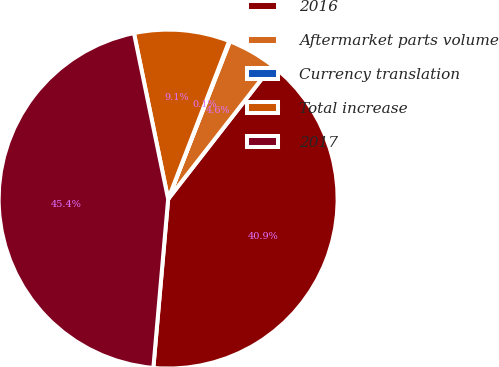<chart> <loc_0><loc_0><loc_500><loc_500><pie_chart><fcel>2016<fcel>Aftermarket parts volume<fcel>Currency translation<fcel>Total increase<fcel>2017<nl><fcel>40.86%<fcel>4.59%<fcel>0.07%<fcel>9.1%<fcel>45.37%<nl></chart> 